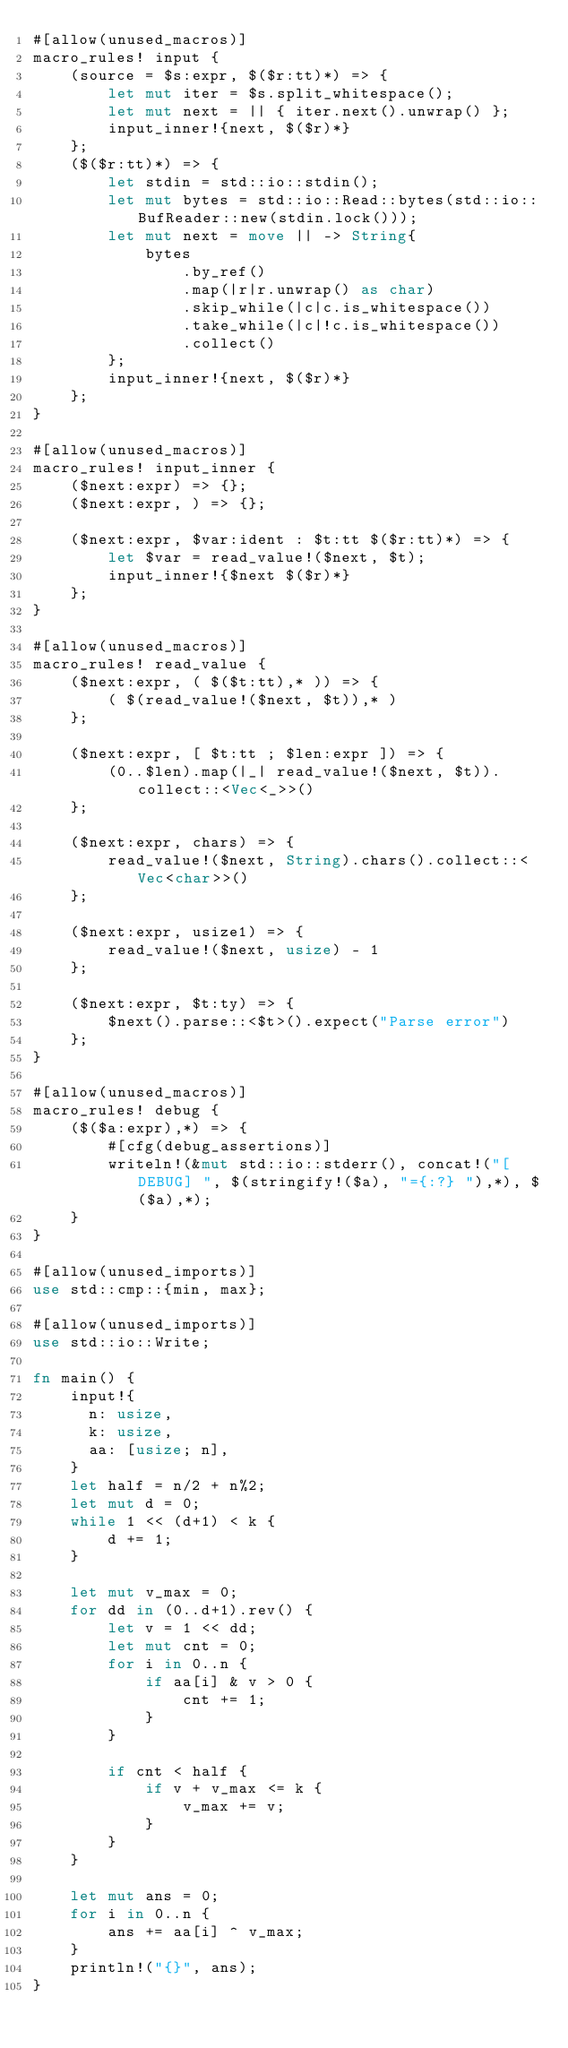Convert code to text. <code><loc_0><loc_0><loc_500><loc_500><_Rust_>#[allow(unused_macros)]
macro_rules! input {
    (source = $s:expr, $($r:tt)*) => {
        let mut iter = $s.split_whitespace();
        let mut next = || { iter.next().unwrap() };
        input_inner!{next, $($r)*}
    };
    ($($r:tt)*) => {
        let stdin = std::io::stdin();
        let mut bytes = std::io::Read::bytes(std::io::BufReader::new(stdin.lock()));
        let mut next = move || -> String{
            bytes
                .by_ref()
                .map(|r|r.unwrap() as char)
                .skip_while(|c|c.is_whitespace())
                .take_while(|c|!c.is_whitespace())
                .collect()
        };
        input_inner!{next, $($r)*}
    };
}

#[allow(unused_macros)]
macro_rules! input_inner {
    ($next:expr) => {};
    ($next:expr, ) => {};

    ($next:expr, $var:ident : $t:tt $($r:tt)*) => {
        let $var = read_value!($next, $t);
        input_inner!{$next $($r)*}
    };
}

#[allow(unused_macros)]
macro_rules! read_value {
    ($next:expr, ( $($t:tt),* )) => {
        ( $(read_value!($next, $t)),* )
    };

    ($next:expr, [ $t:tt ; $len:expr ]) => {
        (0..$len).map(|_| read_value!($next, $t)).collect::<Vec<_>>()
    };

    ($next:expr, chars) => {
        read_value!($next, String).chars().collect::<Vec<char>>()
    };

    ($next:expr, usize1) => {
        read_value!($next, usize) - 1
    };

    ($next:expr, $t:ty) => {
        $next().parse::<$t>().expect("Parse error")
    };
}

#[allow(unused_macros)]
macro_rules! debug {
    ($($a:expr),*) => {
        #[cfg(debug_assertions)]
        writeln!(&mut std::io::stderr(), concat!("[DEBUG] ", $(stringify!($a), "={:?} "),*), $($a),*);
    }
}

#[allow(unused_imports)]
use std::cmp::{min, max};

#[allow(unused_imports)]
use std::io::Write;

fn main() {
    input!{
      n: usize,
      k: usize,
      aa: [usize; n],
    }
    let half = n/2 + n%2;
    let mut d = 0;
    while 1 << (d+1) < k {
        d += 1;
    }

    let mut v_max = 0;
    for dd in (0..d+1).rev() {
        let v = 1 << dd;
        let mut cnt = 0;
        for i in 0..n {
            if aa[i] & v > 0 {
                cnt += 1;
            }
        }

        if cnt < half {
            if v + v_max <= k {
                v_max += v;
            }
        }
    }

    let mut ans = 0;
    for i in 0..n {
        ans += aa[i] ^ v_max;
    }
    println!("{}", ans);
}</code> 